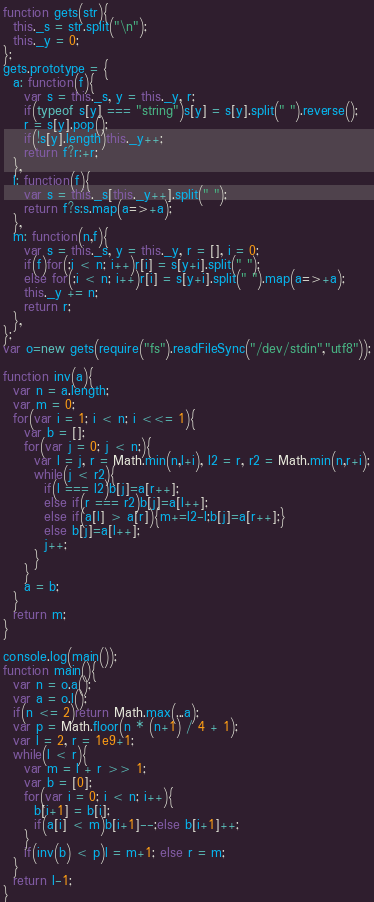Convert code to text. <code><loc_0><loc_0><loc_500><loc_500><_JavaScript_>function gets(str){
  this._s = str.split("\n");
  this._y = 0;
};
gets.prototype = {
  a: function(f){
    var s = this._s, y = this._y, r;
    if(typeof s[y] === "string")s[y] = s[y].split(" ").reverse();
    r = s[y].pop();
    if(!s[y].length)this._y++;
    return f?r:+r;
  },
  l: function(f){
    var s = this._s[this._y++].split(" ");
    return f?s:s.map(a=>+a);
  },
  m: function(n,f){
    var s = this._s, y = this._y, r = [], i = 0;
    if(f)for(;i < n; i++)r[i] = s[y+i].split(" ");
    else for(;i < n; i++)r[i] = s[y+i].split(" ").map(a=>+a);
    this._y += n;
    return r;
  },
};
var o=new gets(require("fs").readFileSync("/dev/stdin","utf8"));

function inv(a){
  var n = a.length;
  var m = 0;
  for(var i = 1; i < n; i <<= 1){
    var b = [];
    for(var j = 0; j < n;){
      var l = j, r = Math.min(n,l+i), l2 = r, r2 = Math.min(n,r+i);
      while(j < r2){
        if(l === l2)b[j]=a[r++];
        else if(r === r2)b[j]=a[l++];
        else if(a[l] > a[r]){m+=l2-l;b[j]=a[r++];}
        else b[j]=a[l++];
        j++;
      }
    }
    a = b;
  }
  return m;
}

console.log(main());
function main(){
  var n = o.a();
  var a = o.l();
  if(n <= 2)return Math.max(...a);
  var p = Math.floor(n * (n+1) / 4 + 1);
  var l = 2, r = 1e9+1;
  while(l < r){
    var m = l + r >> 1;
    var b = [0];
    for(var i = 0; i < n; i++){
      b[i+1] = b[i];
      if(a[i] < m)b[i+1]--;else b[i+1]++;
    }
    if(inv(b) < p)l = m+1; else r = m;
  }
  return l-1;
}</code> 